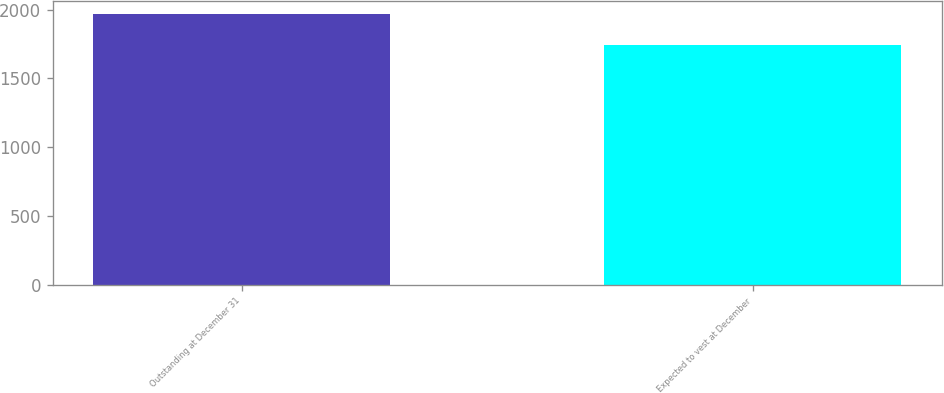<chart> <loc_0><loc_0><loc_500><loc_500><bar_chart><fcel>Outstanding at December 31<fcel>Expected to vest at December<nl><fcel>1968<fcel>1744<nl></chart> 